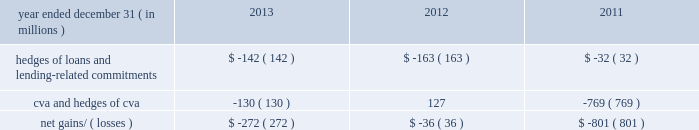Management 2019s discussion and analysis 138 jpmorgan chase & co./2013 annual report the credit derivatives used in credit portfolio management activities do not qualify for hedge accounting under u.s .
Gaap ; these derivatives are reported at fair value , with gains and losses recognized in principal transactions revenue .
In contrast , the loans and lending-related commitments being risk-managed are accounted for on an accrual basis .
This asymmetry in accounting treatment , between loans and lending-related commitments and the credit derivatives used in credit portfolio management activities , causes earnings volatility that is not representative , in the firm 2019s view , of the true changes in value of the firm 2019s overall credit exposure .
The effectiveness of the firm 2019s credit default swap ( 201ccds 201d ) protection as a hedge of the firm 2019s exposures may vary depending on a number of factors , including the named reference entity ( i.e. , the firm may experience losses on specific exposures that are different than the named reference entities in the purchased cds ) , and the contractual terms of the cds ( which may have a defined credit event that does not align with an actual loss realized by the firm ) and the maturity of the firm 2019s cds protection ( which in some cases may be shorter than the firm 2019s exposures ) .
However , the firm generally seeks to purchase credit protection with a maturity date that is the same or similar to the maturity date of the exposure for which the protection was purchased , and remaining differences in maturity are actively monitored and managed by the firm .
Credit portfolio hedges the table sets out the fair value related to the firm 2019s credit derivatives used in credit portfolio management activities , the fair value related to the cva ( which reflects the credit quality of derivatives counterparty exposure ) , as well as certain other hedges used in the risk management of cva .
These results can vary from period-to- period due to market conditions that affect specific positions in the portfolio .
Net gains and losses on credit portfolio hedges year ended december 31 , ( in millions ) 2013 2012 2011 hedges of loans and lending- related commitments $ ( 142 ) $ ( 163 ) $ ( 32 ) .
Community reinvestment act exposure the community reinvestment act ( 201ccra 201d ) encourages banks to meet the credit needs of borrowers in all segments of their communities , including neighborhoods with low or moderate incomes .
The firm is a national leader in community development by providing loans , investments and community development services in communities across the united states .
At december 31 , 2013 and 2012 , the firm 2019s cra loan portfolio was approximately $ 18 billion and $ 16 billion , respectively .
At december 31 , 2013 and 2012 , 50% ( 50 % ) and 62% ( 62 % ) , respectively , of the cra portfolio were residential mortgage loans ; 26% ( 26 % ) and 13% ( 13 % ) , respectively , were commercial real estate loans ; 16% ( 16 % ) and 18% ( 18 % ) , respectively , were business banking loans ; and 8% ( 8 % ) and 7% ( 7 % ) , respectively , were other loans .
Cra nonaccrual loans were 3% ( 3 % ) and 4% ( 4 % ) , respectively , of the firm 2019s total nonaccrual loans .
For the years ended december 31 , 2013 and 2012 , net charge-offs in the cra portfolio were 1% ( 1 % ) and 3% ( 3 % ) , respectively , of the firm 2019s net charge-offs in both years. .
In 2013 what was the percent of the total hedges of loans and lending- related commitments that was cva and hedges of cva? 
Computations: (130 / 272)
Answer: 0.47794. Management 2019s discussion and analysis 138 jpmorgan chase & co./2013 annual report the credit derivatives used in credit portfolio management activities do not qualify for hedge accounting under u.s .
Gaap ; these derivatives are reported at fair value , with gains and losses recognized in principal transactions revenue .
In contrast , the loans and lending-related commitments being risk-managed are accounted for on an accrual basis .
This asymmetry in accounting treatment , between loans and lending-related commitments and the credit derivatives used in credit portfolio management activities , causes earnings volatility that is not representative , in the firm 2019s view , of the true changes in value of the firm 2019s overall credit exposure .
The effectiveness of the firm 2019s credit default swap ( 201ccds 201d ) protection as a hedge of the firm 2019s exposures may vary depending on a number of factors , including the named reference entity ( i.e. , the firm may experience losses on specific exposures that are different than the named reference entities in the purchased cds ) , and the contractual terms of the cds ( which may have a defined credit event that does not align with an actual loss realized by the firm ) and the maturity of the firm 2019s cds protection ( which in some cases may be shorter than the firm 2019s exposures ) .
However , the firm generally seeks to purchase credit protection with a maturity date that is the same or similar to the maturity date of the exposure for which the protection was purchased , and remaining differences in maturity are actively monitored and managed by the firm .
Credit portfolio hedges the table sets out the fair value related to the firm 2019s credit derivatives used in credit portfolio management activities , the fair value related to the cva ( which reflects the credit quality of derivatives counterparty exposure ) , as well as certain other hedges used in the risk management of cva .
These results can vary from period-to- period due to market conditions that affect specific positions in the portfolio .
Net gains and losses on credit portfolio hedges year ended december 31 , ( in millions ) 2013 2012 2011 hedges of loans and lending- related commitments $ ( 142 ) $ ( 163 ) $ ( 32 ) .
Community reinvestment act exposure the community reinvestment act ( 201ccra 201d ) encourages banks to meet the credit needs of borrowers in all segments of their communities , including neighborhoods with low or moderate incomes .
The firm is a national leader in community development by providing loans , investments and community development services in communities across the united states .
At december 31 , 2013 and 2012 , the firm 2019s cra loan portfolio was approximately $ 18 billion and $ 16 billion , respectively .
At december 31 , 2013 and 2012 , 50% ( 50 % ) and 62% ( 62 % ) , respectively , of the cra portfolio were residential mortgage loans ; 26% ( 26 % ) and 13% ( 13 % ) , respectively , were commercial real estate loans ; 16% ( 16 % ) and 18% ( 18 % ) , respectively , were business banking loans ; and 8% ( 8 % ) and 7% ( 7 % ) , respectively , were other loans .
Cra nonaccrual loans were 3% ( 3 % ) and 4% ( 4 % ) , respectively , of the firm 2019s total nonaccrual loans .
For the years ended december 31 , 2013 and 2012 , net charge-offs in the cra portfolio were 1% ( 1 % ) and 3% ( 3 % ) , respectively , of the firm 2019s net charge-offs in both years. .
At december 31 , 2013 , what percent of loans were non-residential loans? 
Computations: (26 + 16)
Answer: 42.0. Management 2019s discussion and analysis 138 jpmorgan chase & co./2013 annual report the credit derivatives used in credit portfolio management activities do not qualify for hedge accounting under u.s .
Gaap ; these derivatives are reported at fair value , with gains and losses recognized in principal transactions revenue .
In contrast , the loans and lending-related commitments being risk-managed are accounted for on an accrual basis .
This asymmetry in accounting treatment , between loans and lending-related commitments and the credit derivatives used in credit portfolio management activities , causes earnings volatility that is not representative , in the firm 2019s view , of the true changes in value of the firm 2019s overall credit exposure .
The effectiveness of the firm 2019s credit default swap ( 201ccds 201d ) protection as a hedge of the firm 2019s exposures may vary depending on a number of factors , including the named reference entity ( i.e. , the firm may experience losses on specific exposures that are different than the named reference entities in the purchased cds ) , and the contractual terms of the cds ( which may have a defined credit event that does not align with an actual loss realized by the firm ) and the maturity of the firm 2019s cds protection ( which in some cases may be shorter than the firm 2019s exposures ) .
However , the firm generally seeks to purchase credit protection with a maturity date that is the same or similar to the maturity date of the exposure for which the protection was purchased , and remaining differences in maturity are actively monitored and managed by the firm .
Credit portfolio hedges the table sets out the fair value related to the firm 2019s credit derivatives used in credit portfolio management activities , the fair value related to the cva ( which reflects the credit quality of derivatives counterparty exposure ) , as well as certain other hedges used in the risk management of cva .
These results can vary from period-to- period due to market conditions that affect specific positions in the portfolio .
Net gains and losses on credit portfolio hedges year ended december 31 , ( in millions ) 2013 2012 2011 hedges of loans and lending- related commitments $ ( 142 ) $ ( 163 ) $ ( 32 ) .
Community reinvestment act exposure the community reinvestment act ( 201ccra 201d ) encourages banks to meet the credit needs of borrowers in all segments of their communities , including neighborhoods with low or moderate incomes .
The firm is a national leader in community development by providing loans , investments and community development services in communities across the united states .
At december 31 , 2013 and 2012 , the firm 2019s cra loan portfolio was approximately $ 18 billion and $ 16 billion , respectively .
At december 31 , 2013 and 2012 , 50% ( 50 % ) and 62% ( 62 % ) , respectively , of the cra portfolio were residential mortgage loans ; 26% ( 26 % ) and 13% ( 13 % ) , respectively , were commercial real estate loans ; 16% ( 16 % ) and 18% ( 18 % ) , respectively , were business banking loans ; and 8% ( 8 % ) and 7% ( 7 % ) , respectively , were other loans .
Cra nonaccrual loans were 3% ( 3 % ) and 4% ( 4 % ) , respectively , of the firm 2019s total nonaccrual loans .
For the years ended december 31 , 2013 and 2012 , net charge-offs in the cra portfolio were 1% ( 1 % ) and 3% ( 3 % ) , respectively , of the firm 2019s net charge-offs in both years. .
What was the ratio of the firm 2019s cra loan portfolio in 2013 compared to 2012? 
Computations: (18 / 16)
Answer: 1.125. 